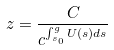<formula> <loc_0><loc_0><loc_500><loc_500>z = \frac { C } { c ^ { \int _ { s _ { 0 } } ^ { g } U ( s ) d s } }</formula> 